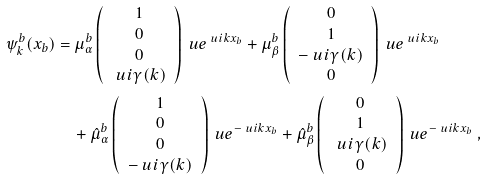<formula> <loc_0><loc_0><loc_500><loc_500>\psi _ { k } ^ { b } ( x _ { b } ) & = \mu _ { \alpha } ^ { b } \left ( \begin{array} { c } 1 \\ 0 \\ 0 \\ \ u i \gamma ( k ) \\ \end{array} \right ) \ u e ^ { \ u i k x _ { b } } + \mu _ { \beta } ^ { b } \left ( \begin{array} { c } 0 \\ 1 \\ - \ u i \gamma ( k ) \\ 0 \\ \end{array} \right ) \ u e ^ { \ u i k x _ { b } } \\ & \quad + \hat { \mu } _ { \alpha } ^ { b } \left ( \begin{array} { c } 1 \\ 0 \\ 0 \\ - \ u i \gamma ( k ) \\ \end{array} \right ) \ u e ^ { - \ u i k x _ { b } } + \hat { \mu } _ { \beta } ^ { b } \left ( \begin{array} { c } 0 \\ 1 \\ \ u i \gamma ( k ) \\ 0 \\ \end{array} \right ) \ u e ^ { - \ u i k x _ { b } } \ ,</formula> 